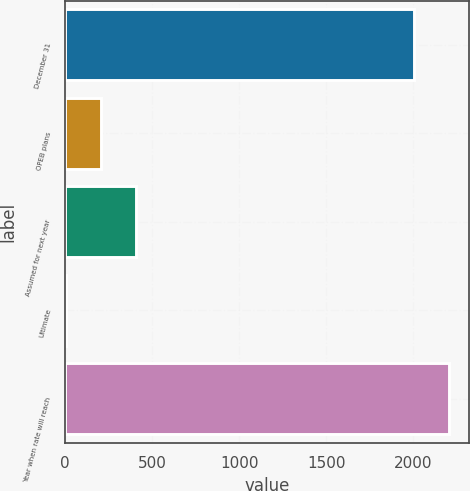Convert chart to OTSL. <chart><loc_0><loc_0><loc_500><loc_500><bar_chart><fcel>December 31<fcel>OPEB plans<fcel>Assumed for next year<fcel>Ultimate<fcel>Year when rate will reach<nl><fcel>2006<fcel>204.6<fcel>405.2<fcel>4<fcel>2206.6<nl></chart> 